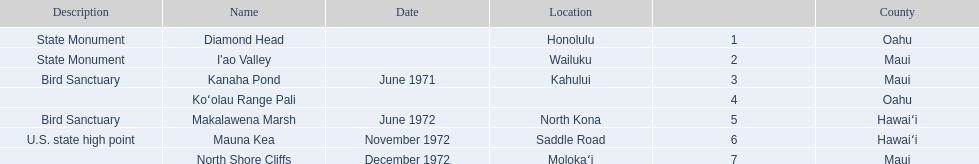What are the names of the different hawaiian national landmarks Diamond Head, I'ao Valley, Kanaha Pond, Koʻolau Range Pali, Makalawena Marsh, Mauna Kea, North Shore Cliffs. Which landmark does not have a location listed? Koʻolau Range Pali. 